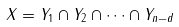<formula> <loc_0><loc_0><loc_500><loc_500>X = Y _ { 1 } \cap Y _ { 2 } \cap \cdots \cap Y _ { n - d }</formula> 